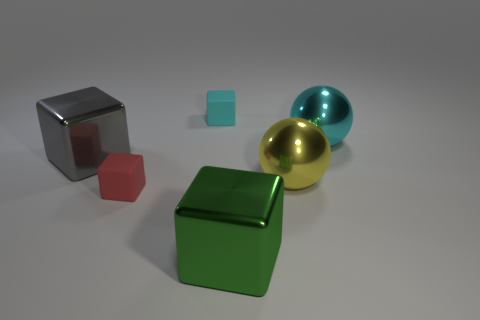Subtract 1 blocks. How many blocks are left? 3 Subtract all purple spheres. Subtract all purple blocks. How many spheres are left? 2 Add 4 tiny green metal blocks. How many objects exist? 10 Subtract all blocks. How many objects are left? 2 Add 4 small cyan things. How many small cyan things exist? 5 Subtract 0 green cylinders. How many objects are left? 6 Subtract all big gray metallic blocks. Subtract all yellow balls. How many objects are left? 4 Add 1 yellow things. How many yellow things are left? 2 